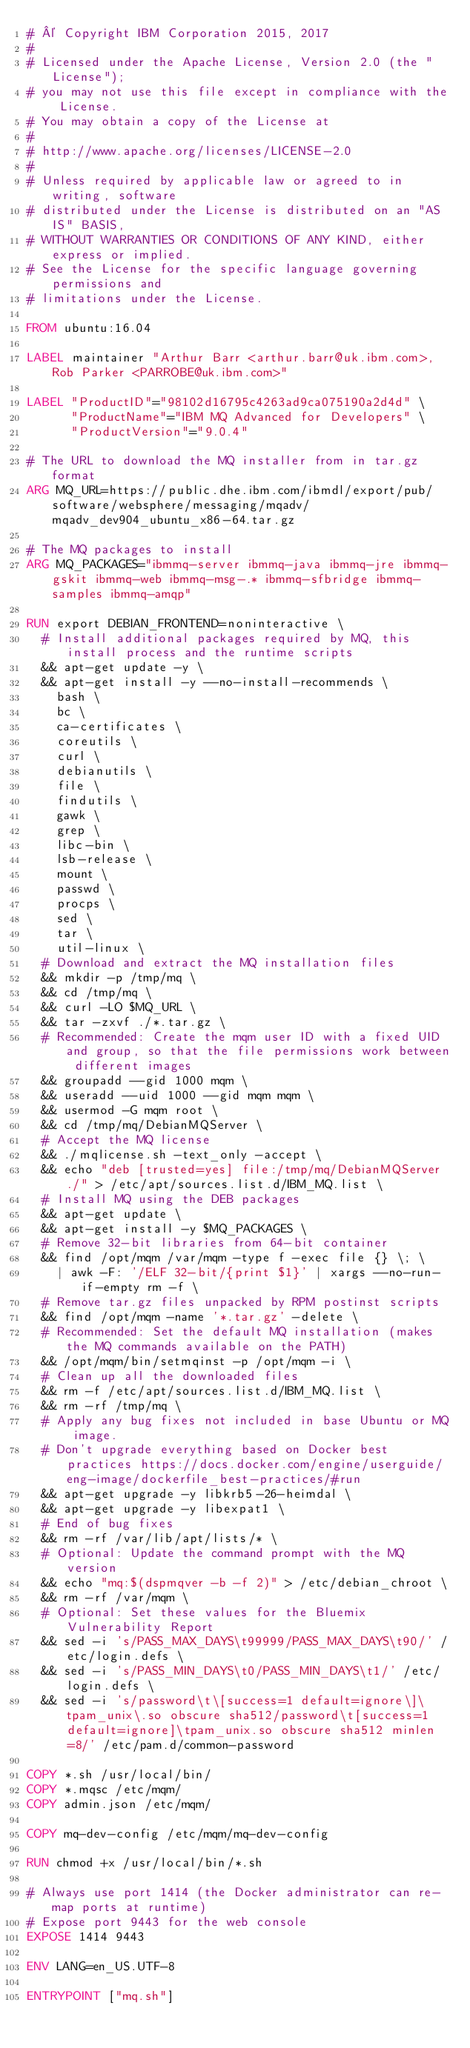Convert code to text. <code><loc_0><loc_0><loc_500><loc_500><_Dockerfile_># © Copyright IBM Corporation 2015, 2017
#
# Licensed under the Apache License, Version 2.0 (the "License");
# you may not use this file except in compliance with the License.
# You may obtain a copy of the License at
#
# http://www.apache.org/licenses/LICENSE-2.0
#
# Unless required by applicable law or agreed to in writing, software
# distributed under the License is distributed on an "AS IS" BASIS,
# WITHOUT WARRANTIES OR CONDITIONS OF ANY KIND, either express or implied.
# See the License for the specific language governing permissions and
# limitations under the License.

FROM ubuntu:16.04

LABEL maintainer "Arthur Barr <arthur.barr@uk.ibm.com>, Rob Parker <PARROBE@uk.ibm.com>"

LABEL "ProductID"="98102d16795c4263ad9ca075190a2d4d" \
      "ProductName"="IBM MQ Advanced for Developers" \
      "ProductVersion"="9.0.4"

# The URL to download the MQ installer from in tar.gz format
ARG MQ_URL=https://public.dhe.ibm.com/ibmdl/export/pub/software/websphere/messaging/mqadv/mqadv_dev904_ubuntu_x86-64.tar.gz

# The MQ packages to install
ARG MQ_PACKAGES="ibmmq-server ibmmq-java ibmmq-jre ibmmq-gskit ibmmq-web ibmmq-msg-.* ibmmq-sfbridge ibmmq-samples ibmmq-amqp"

RUN export DEBIAN_FRONTEND=noninteractive \
  # Install additional packages required by MQ, this install process and the runtime scripts
  && apt-get update -y \
  && apt-get install -y --no-install-recommends \
    bash \
    bc \
    ca-certificates \
    coreutils \
    curl \
    debianutils \
    file \
    findutils \
    gawk \
    grep \
    libc-bin \
    lsb-release \
    mount \
    passwd \
    procps \
    sed \
    tar \
    util-linux \
  # Download and extract the MQ installation files
  && mkdir -p /tmp/mq \
  && cd /tmp/mq \
  && curl -LO $MQ_URL \
  && tar -zxvf ./*.tar.gz \
  # Recommended: Create the mqm user ID with a fixed UID and group, so that the file permissions work between different images
  && groupadd --gid 1000 mqm \
  && useradd --uid 1000 --gid mqm mqm \
  && usermod -G mqm root \
  && cd /tmp/mq/DebianMQServer \
  # Accept the MQ license
  && ./mqlicense.sh -text_only -accept \
  && echo "deb [trusted=yes] file:/tmp/mq/DebianMQServer ./" > /etc/apt/sources.list.d/IBM_MQ.list \
  # Install MQ using the DEB packages
  && apt-get update \
  && apt-get install -y $MQ_PACKAGES \
  # Remove 32-bit libraries from 64-bit container
  && find /opt/mqm /var/mqm -type f -exec file {} \; \
    | awk -F: '/ELF 32-bit/{print $1}' | xargs --no-run-if-empty rm -f \
  # Remove tar.gz files unpacked by RPM postinst scripts
  && find /opt/mqm -name '*.tar.gz' -delete \
  # Recommended: Set the default MQ installation (makes the MQ commands available on the PATH)
  && /opt/mqm/bin/setmqinst -p /opt/mqm -i \
  # Clean up all the downloaded files
  && rm -f /etc/apt/sources.list.d/IBM_MQ.list \
  && rm -rf /tmp/mq \
  # Apply any bug fixes not included in base Ubuntu or MQ image.
  # Don't upgrade everything based on Docker best practices https://docs.docker.com/engine/userguide/eng-image/dockerfile_best-practices/#run
  && apt-get upgrade -y libkrb5-26-heimdal \
  && apt-get upgrade -y libexpat1 \
  # End of bug fixes
  && rm -rf /var/lib/apt/lists/* \
  # Optional: Update the command prompt with the MQ version
  && echo "mq:$(dspmqver -b -f 2)" > /etc/debian_chroot \
  && rm -rf /var/mqm \
  # Optional: Set these values for the Bluemix Vulnerability Report
  && sed -i 's/PASS_MAX_DAYS\t99999/PASS_MAX_DAYS\t90/' /etc/login.defs \
  && sed -i 's/PASS_MIN_DAYS\t0/PASS_MIN_DAYS\t1/' /etc/login.defs \
  && sed -i 's/password\t\[success=1 default=ignore\]\tpam_unix\.so obscure sha512/password\t[success=1 default=ignore]\tpam_unix.so obscure sha512 minlen=8/' /etc/pam.d/common-password

COPY *.sh /usr/local/bin/
COPY *.mqsc /etc/mqm/
COPY admin.json /etc/mqm/

COPY mq-dev-config /etc/mqm/mq-dev-config

RUN chmod +x /usr/local/bin/*.sh

# Always use port 1414 (the Docker administrator can re-map ports at runtime)
# Expose port 9443 for the web console
EXPOSE 1414 9443

ENV LANG=en_US.UTF-8

ENTRYPOINT ["mq.sh"]
</code> 